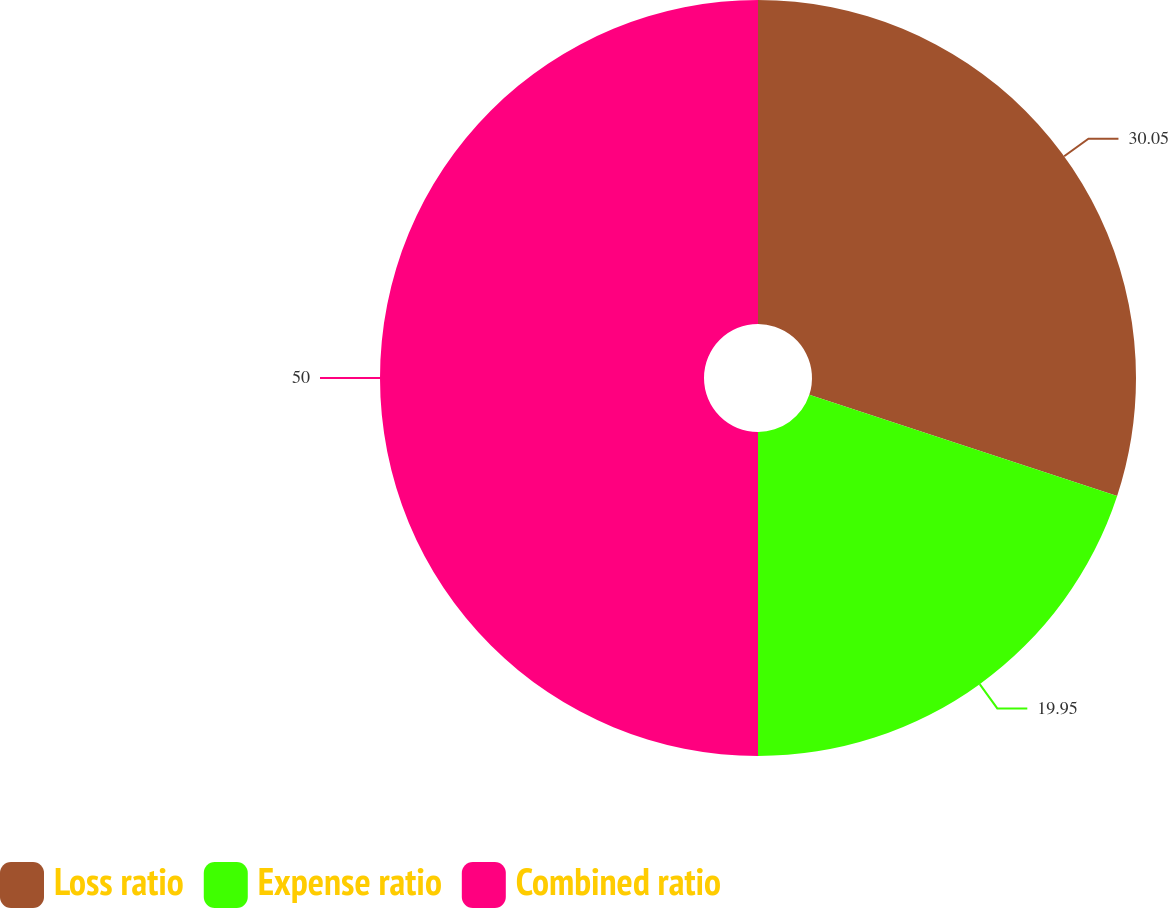<chart> <loc_0><loc_0><loc_500><loc_500><pie_chart><fcel>Loss ratio<fcel>Expense ratio<fcel>Combined ratio<nl><fcel>30.05%<fcel>19.95%<fcel>50.0%<nl></chart> 